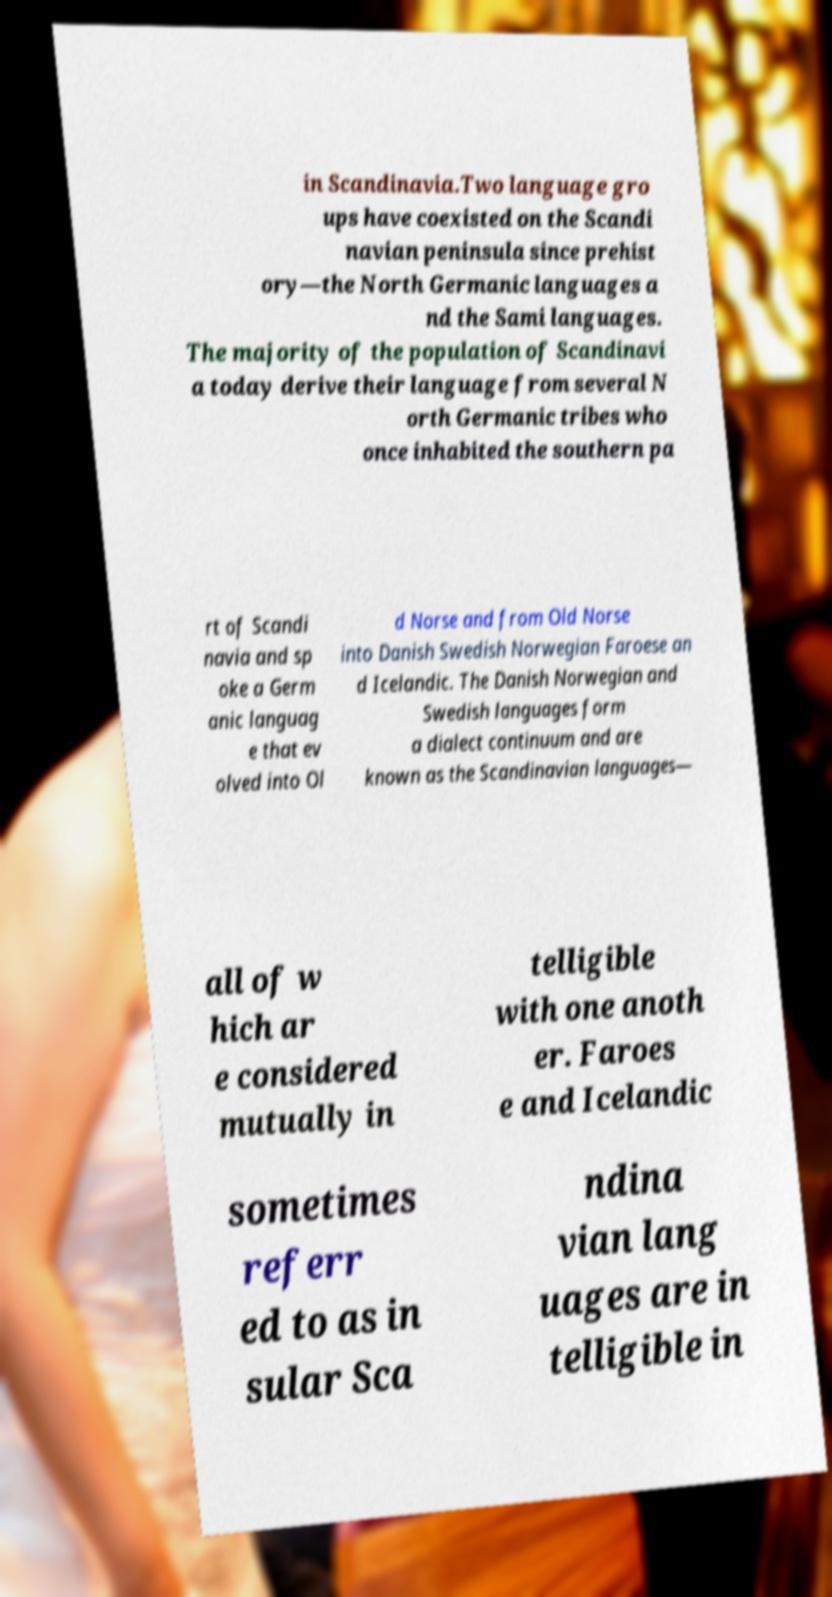There's text embedded in this image that I need extracted. Can you transcribe it verbatim? in Scandinavia.Two language gro ups have coexisted on the Scandi navian peninsula since prehist ory—the North Germanic languages a nd the Sami languages. The majority of the population of Scandinavi a today derive their language from several N orth Germanic tribes who once inhabited the southern pa rt of Scandi navia and sp oke a Germ anic languag e that ev olved into Ol d Norse and from Old Norse into Danish Swedish Norwegian Faroese an d Icelandic. The Danish Norwegian and Swedish languages form a dialect continuum and are known as the Scandinavian languages— all of w hich ar e considered mutually in telligible with one anoth er. Faroes e and Icelandic sometimes referr ed to as in sular Sca ndina vian lang uages are in telligible in 